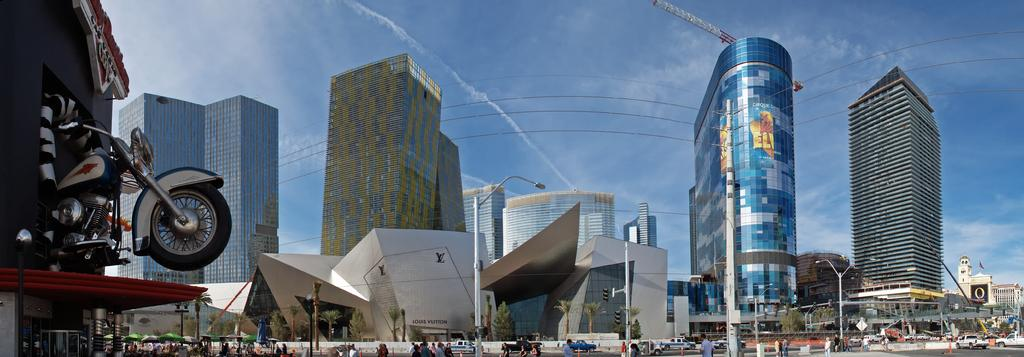What is the weather condition depicted in the image? The sky is cloudy in the image. What type of buildings can be seen in the image? There are buildings with glass windows in the image. What is the purpose of the light pole in the image? The light pole provides illumination in the image. Can you describe the people in the image? There are people present in the image. What types of vehicles are visible in the image? There are vehicles in the image. What type of vegetation is present in the image? There are trees in the image. What mode of transportation is also present in the image? There is a motorbike in the image. Where is the shelf located in the image? There is no shelf present in the image. What color is the egg in the image? There is no egg present in the image. 